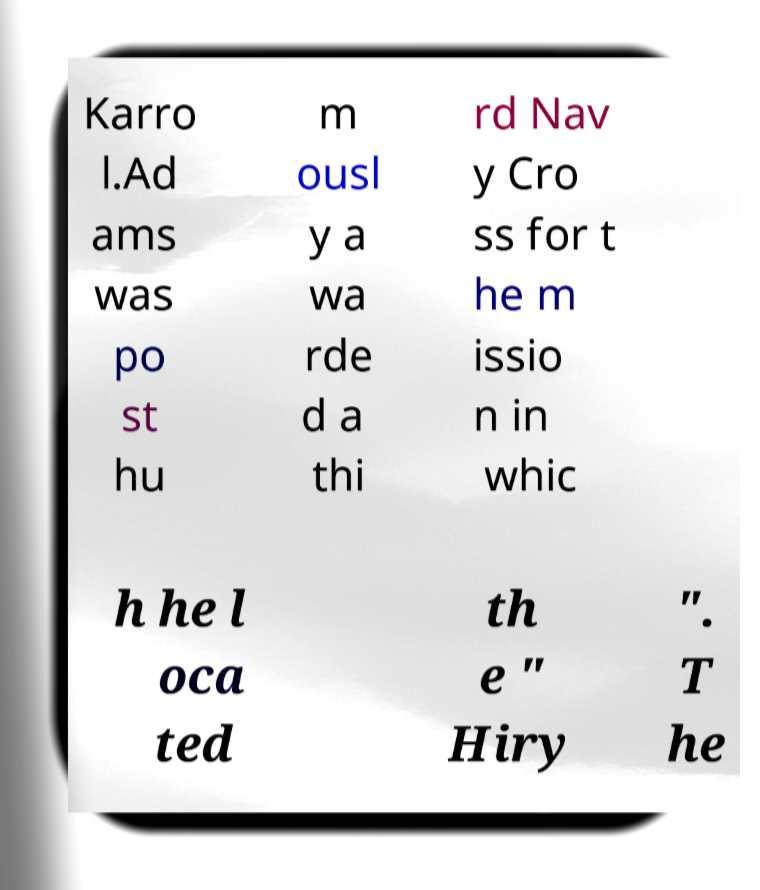What messages or text are displayed in this image? I need them in a readable, typed format. Karro l.Ad ams was po st hu m ousl y a wa rde d a thi rd Nav y Cro ss for t he m issio n in whic h he l oca ted th e " Hiry ". T he 